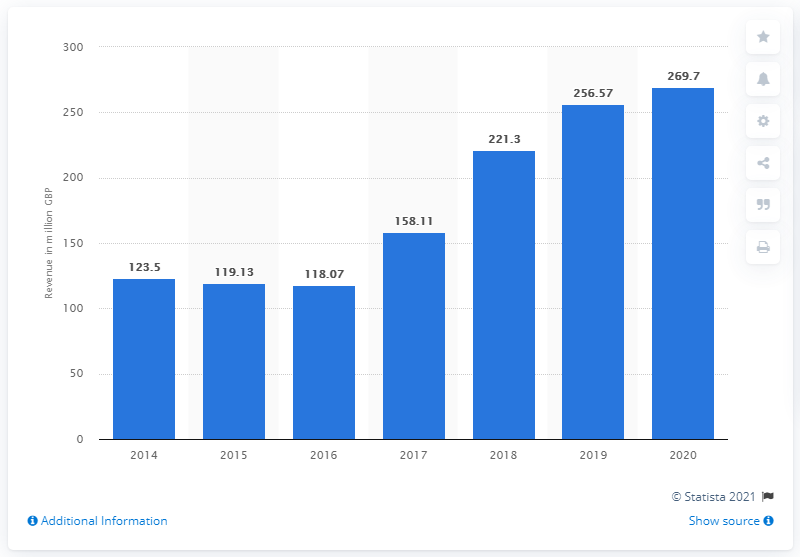Outline some significant characteristics in this image. According to available data, Games Workshop's global revenue in 2019 was 269.7 million US dollars. 